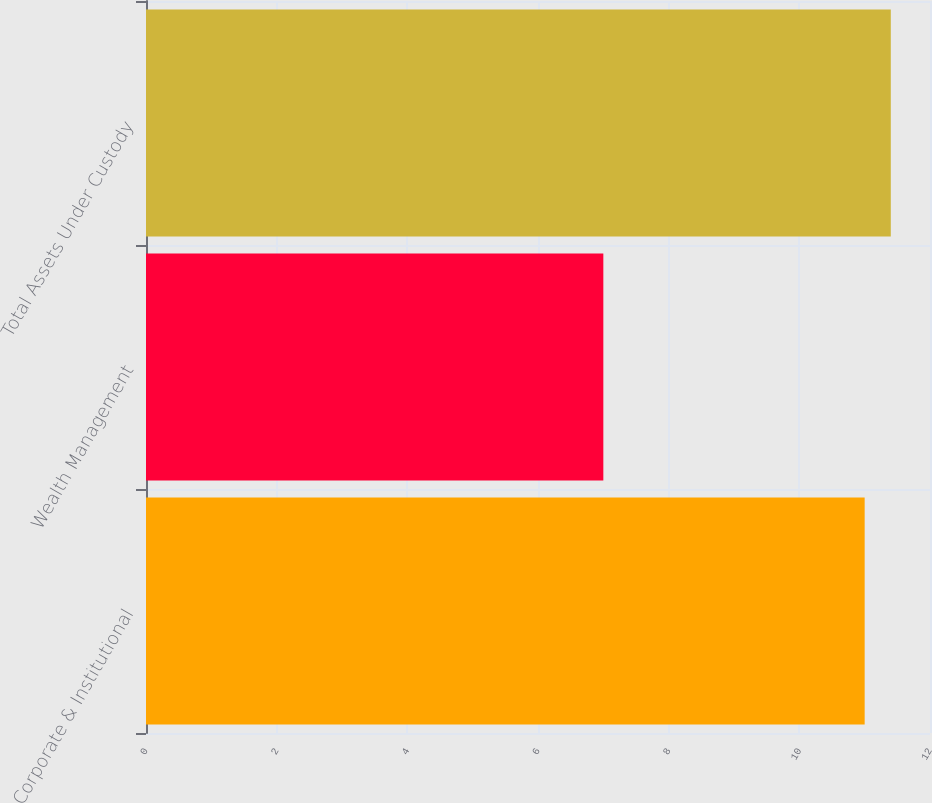<chart> <loc_0><loc_0><loc_500><loc_500><bar_chart><fcel>Corporate & Institutional<fcel>Wealth Management<fcel>Total Assets Under Custody<nl><fcel>11<fcel>7<fcel>11.4<nl></chart> 